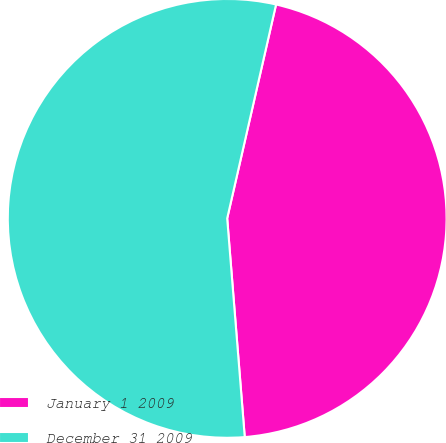Convert chart. <chart><loc_0><loc_0><loc_500><loc_500><pie_chart><fcel>January 1 2009<fcel>December 31 2009<nl><fcel>45.15%<fcel>54.85%<nl></chart> 